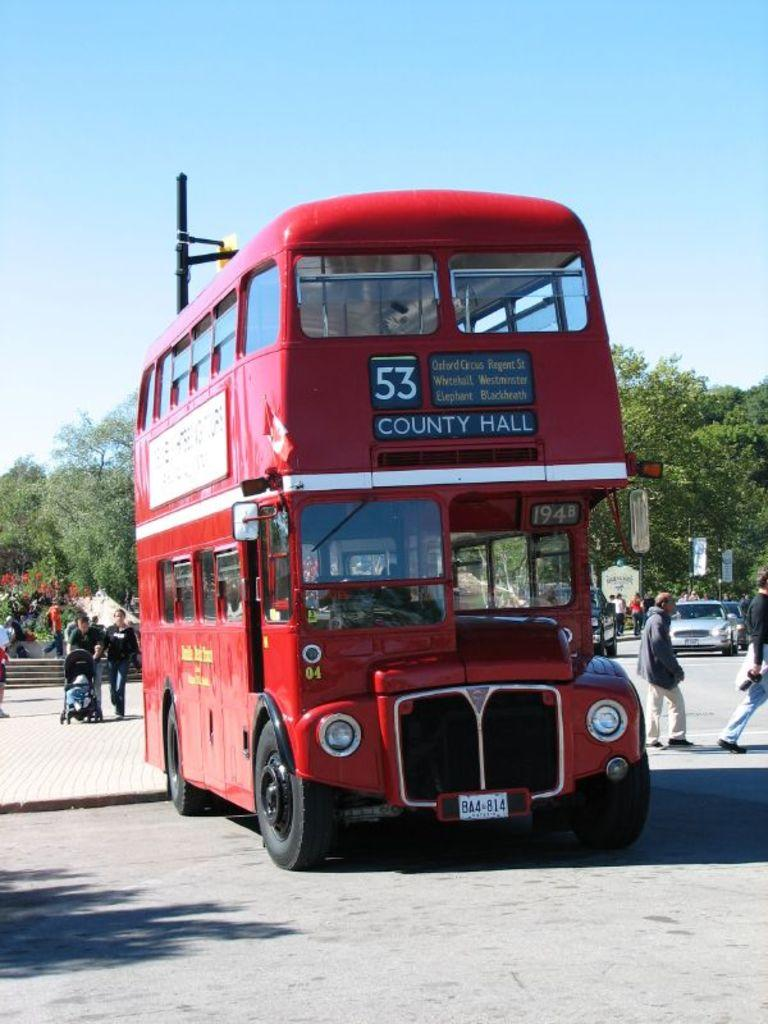What is the main subject of the image? There is a vehicle on the road in the image. Can you describe the background of the image? In the background of the image, there are persons, a kid in a stroller, vehicles, trees, banners, objects, and the sky. What type of objects can be seen in the background? The objects in the background are not specified, but they are present. Are there any cherries growing on the trees in the image? There is no information about cherries or trees bearing fruit in the image. Can you see a plough being used in the image? There is no plough present in the image. Is there a desk visible in the image? There is no desk present in the image. 